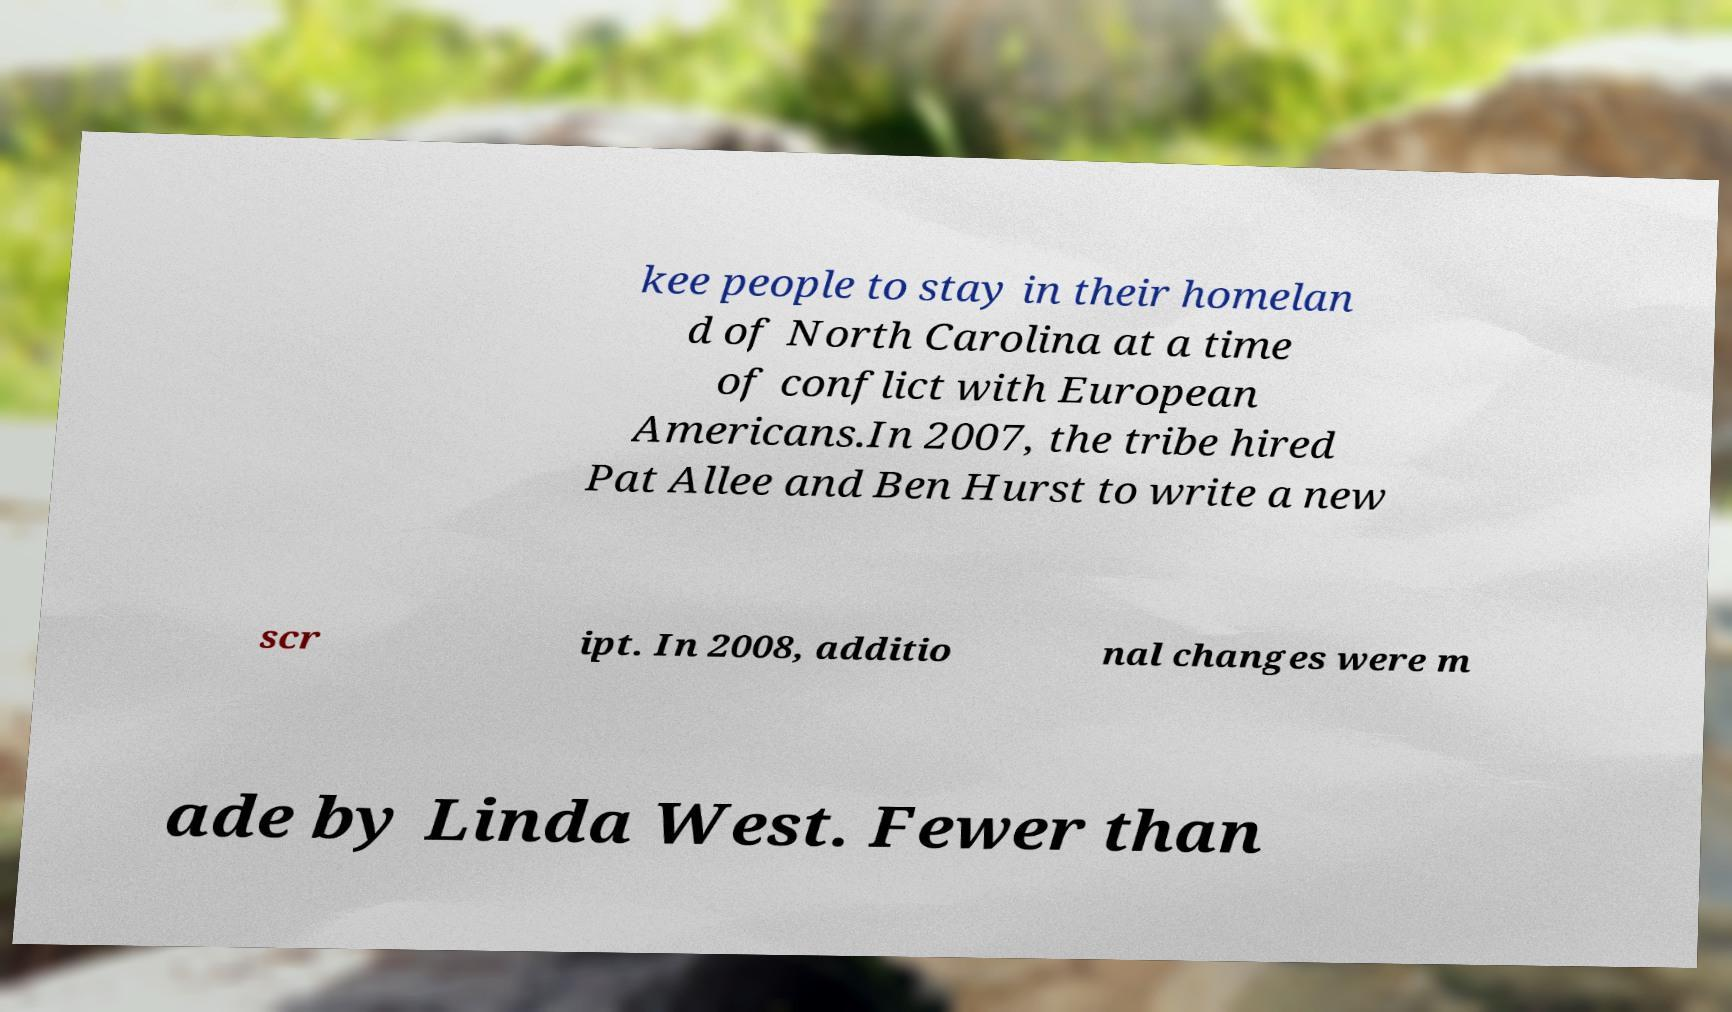Can you accurately transcribe the text from the provided image for me? kee people to stay in their homelan d of North Carolina at a time of conflict with European Americans.In 2007, the tribe hired Pat Allee and Ben Hurst to write a new scr ipt. In 2008, additio nal changes were m ade by Linda West. Fewer than 